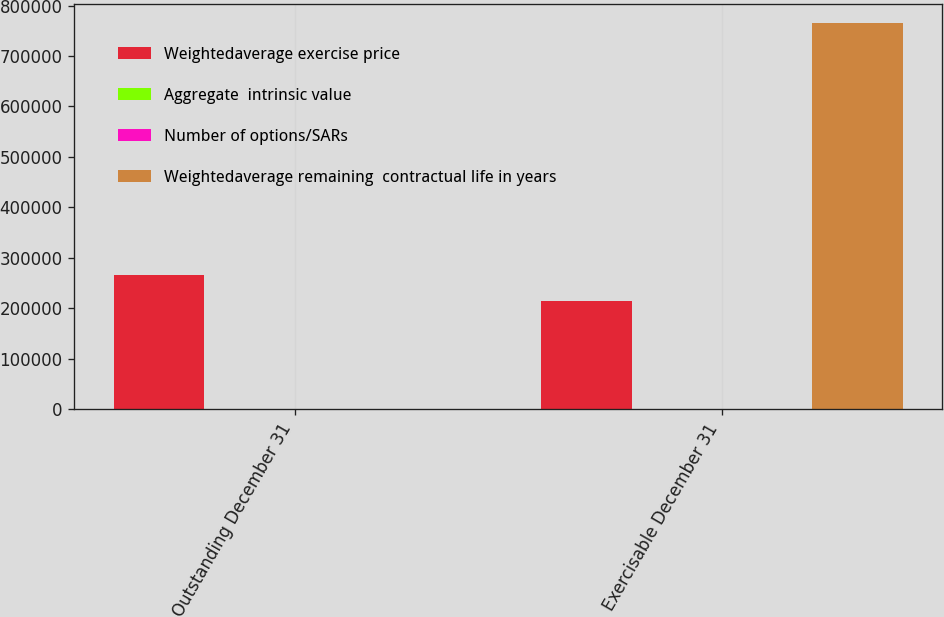<chart> <loc_0><loc_0><loc_500><loc_500><stacked_bar_chart><ecel><fcel>Outstanding December 31<fcel>Exercisable December 31<nl><fcel>Weightedaverage exercise price<fcel>266568<fcel>214443<nl><fcel>Aggregate  intrinsic value<fcel>45.83<fcel>48.94<nl><fcel>Number of options/SARs<fcel>3.4<fcel>2.2<nl><fcel>Weightedaverage remaining  contractual life in years<fcel>48.94<fcel>765276<nl></chart> 